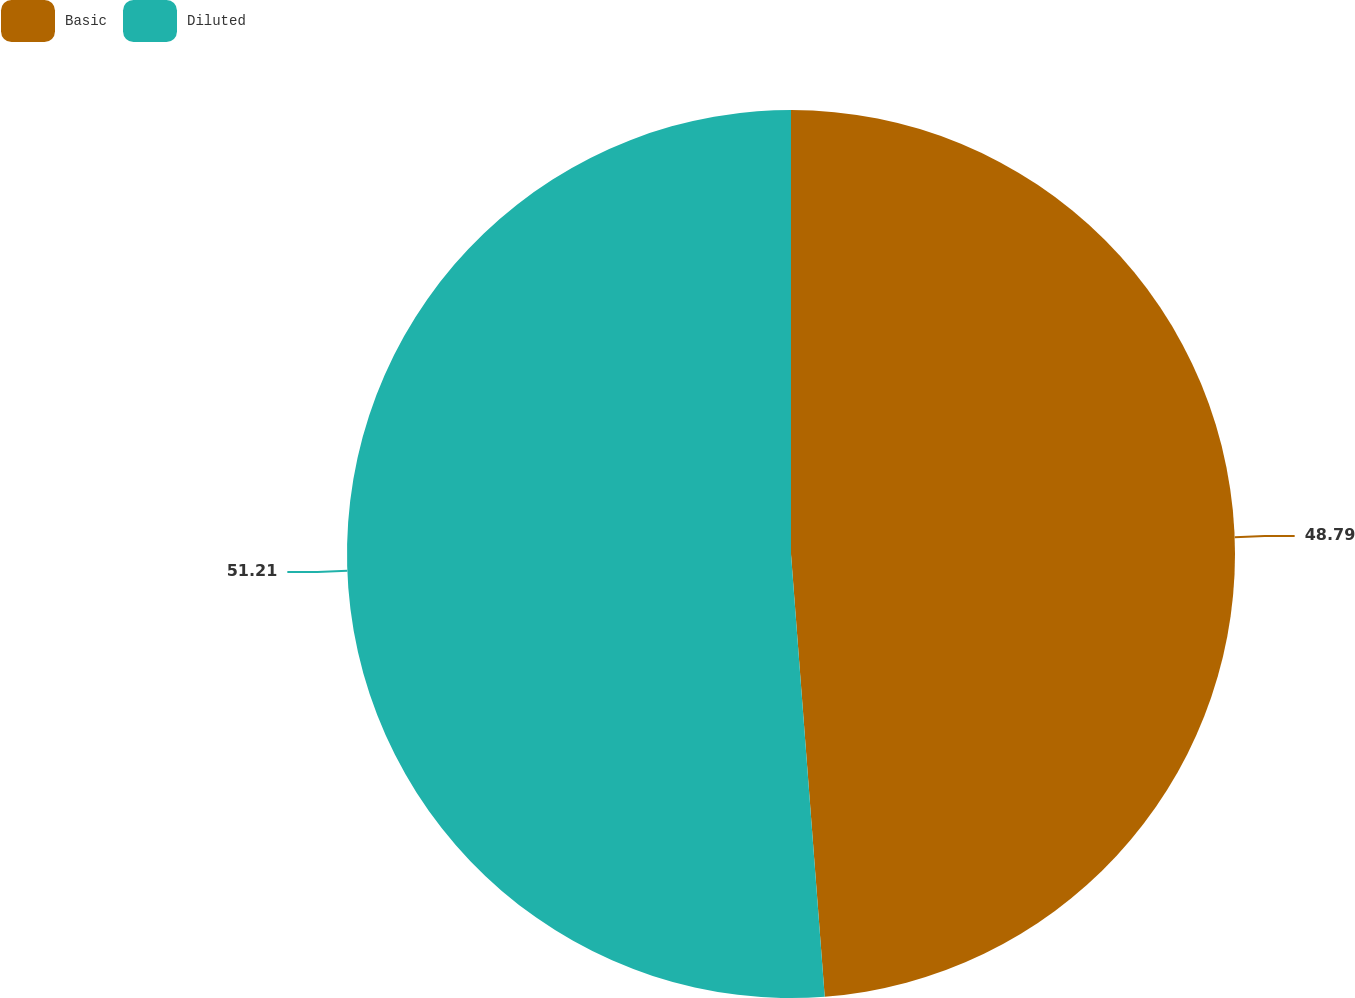<chart> <loc_0><loc_0><loc_500><loc_500><pie_chart><fcel>Basic<fcel>Diluted<nl><fcel>48.79%<fcel>51.21%<nl></chart> 